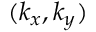<formula> <loc_0><loc_0><loc_500><loc_500>( k _ { x } , k _ { y } )</formula> 